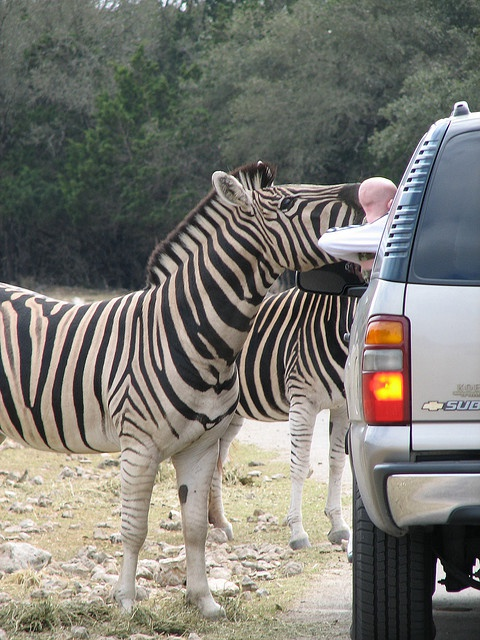Describe the objects in this image and their specific colors. I can see zebra in gray, darkgray, black, and tan tones, car in gray, black, darkgray, and lightgray tones, zebra in gray, black, darkgray, lightgray, and tan tones, people in gray, white, and darkgray tones, and people in gray, darkgray, lavender, and lightpink tones in this image. 